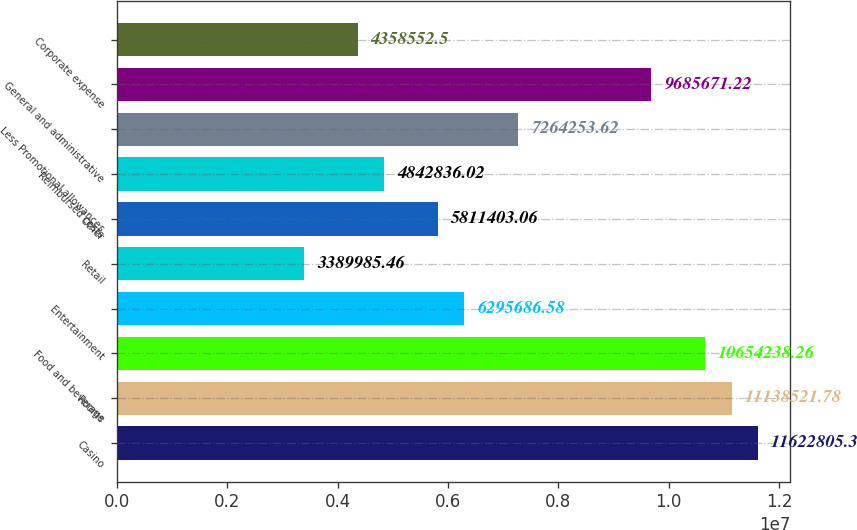Convert chart. <chart><loc_0><loc_0><loc_500><loc_500><bar_chart><fcel>Casino<fcel>Rooms<fcel>Food and beverage<fcel>Entertainment<fcel>Retail<fcel>Other<fcel>Reimbursed costs<fcel>Less Promotional allowances<fcel>General and administrative<fcel>Corporate expense<nl><fcel>1.16228e+07<fcel>1.11385e+07<fcel>1.06542e+07<fcel>6.29569e+06<fcel>3.38999e+06<fcel>5.8114e+06<fcel>4.84284e+06<fcel>7.26425e+06<fcel>9.68567e+06<fcel>4.35855e+06<nl></chart> 